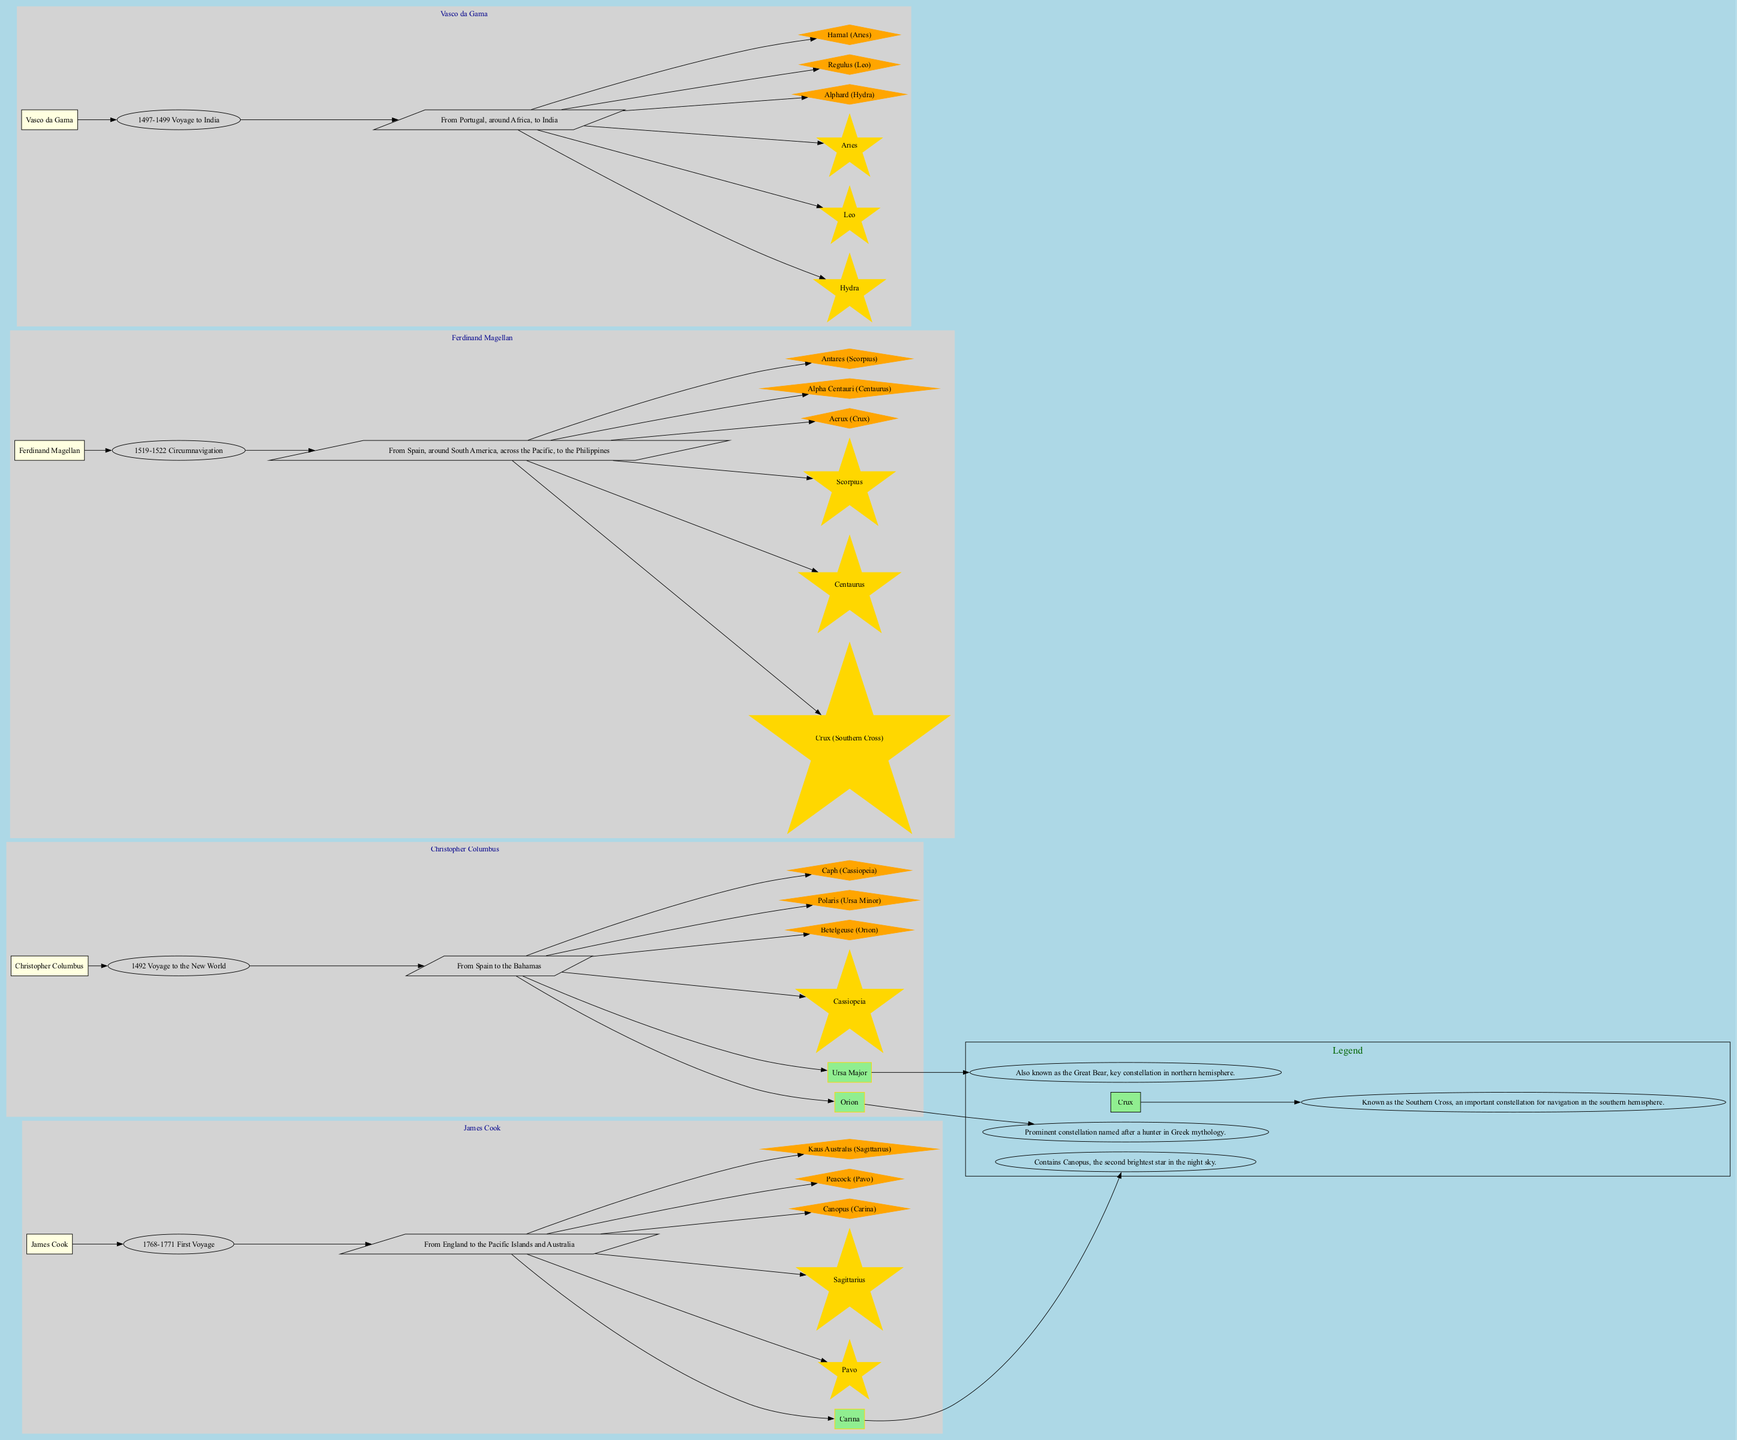What was the route taken by Christopher Columbus? The diagram indicates that Christopher Columbus's route was from Spain to the Bahamas. This information is shown in a parallelogram labeled with the route underneath his journey title.
Answer: From Spain to the Bahamas Which constellations did Ferdinand Magellan use during his exploration? Ferdinand Magellan's exploration route is connected to the constellations Crux, Centaurus, and Scorpius, which are depicted as nodes in the subgraph for his journey.
Answer: Crux, Centaurus, Scorpius How many key stars are associated with James Cook's journey? James Cook's journey is connected to three key stars: Canopus, Peacock, and Kaus Australis, as indicated in the nodes linked to his route. Counting them gives three stars.
Answer: 3 What is the description of the constellation Orion? The diagram provides the description of Orion as a prominent constellation named after a hunter in Greek mythology, shown in the legend section of the diagram.
Answer: Prominent constellation named after a hunter in Greek mythology Which explorer's journey occurred between 1519 and 1522? The diagram directly states that Ferdinand Magellan's journey to circumnavigate the globe occurred from 1519 to 1522, which is indicated in the ellipse labeled with the journey under his name.
Answer: Ferdinand Magellan What is the key star associated with the constellation Carina? The key star associated with Carina is Canopus, which is explicitly mentioned in the subgraph for James Cook's voyage, directly linked to the constellation node.
Answer: Canopus What role did the constellation Crux play in historical naval exploration? Crux, known as the Southern Cross, is depicted as an important constellation for navigation in the southern hemisphere, influencing how navigators like Ferdinand Magellan found their way during voyages. Its purpose is directly tied to the navigation theme of the diagram.
Answer: Navigation in the southern hemisphere Which explorer had a route that went around the African continent? Vasco da Gama is the explorer who had a route that went around Africa to reach India, as shown by the specific path outlined in the diagram.
Answer: Vasco da Gama How many explorers are depicted in the diagram? The diagram includes four explorers: Christopher Columbus, Ferdinand Magellan, James Cook, and Vasco da Gama. This can be determined by counting the subgraphs titled with their names.
Answer: 4 